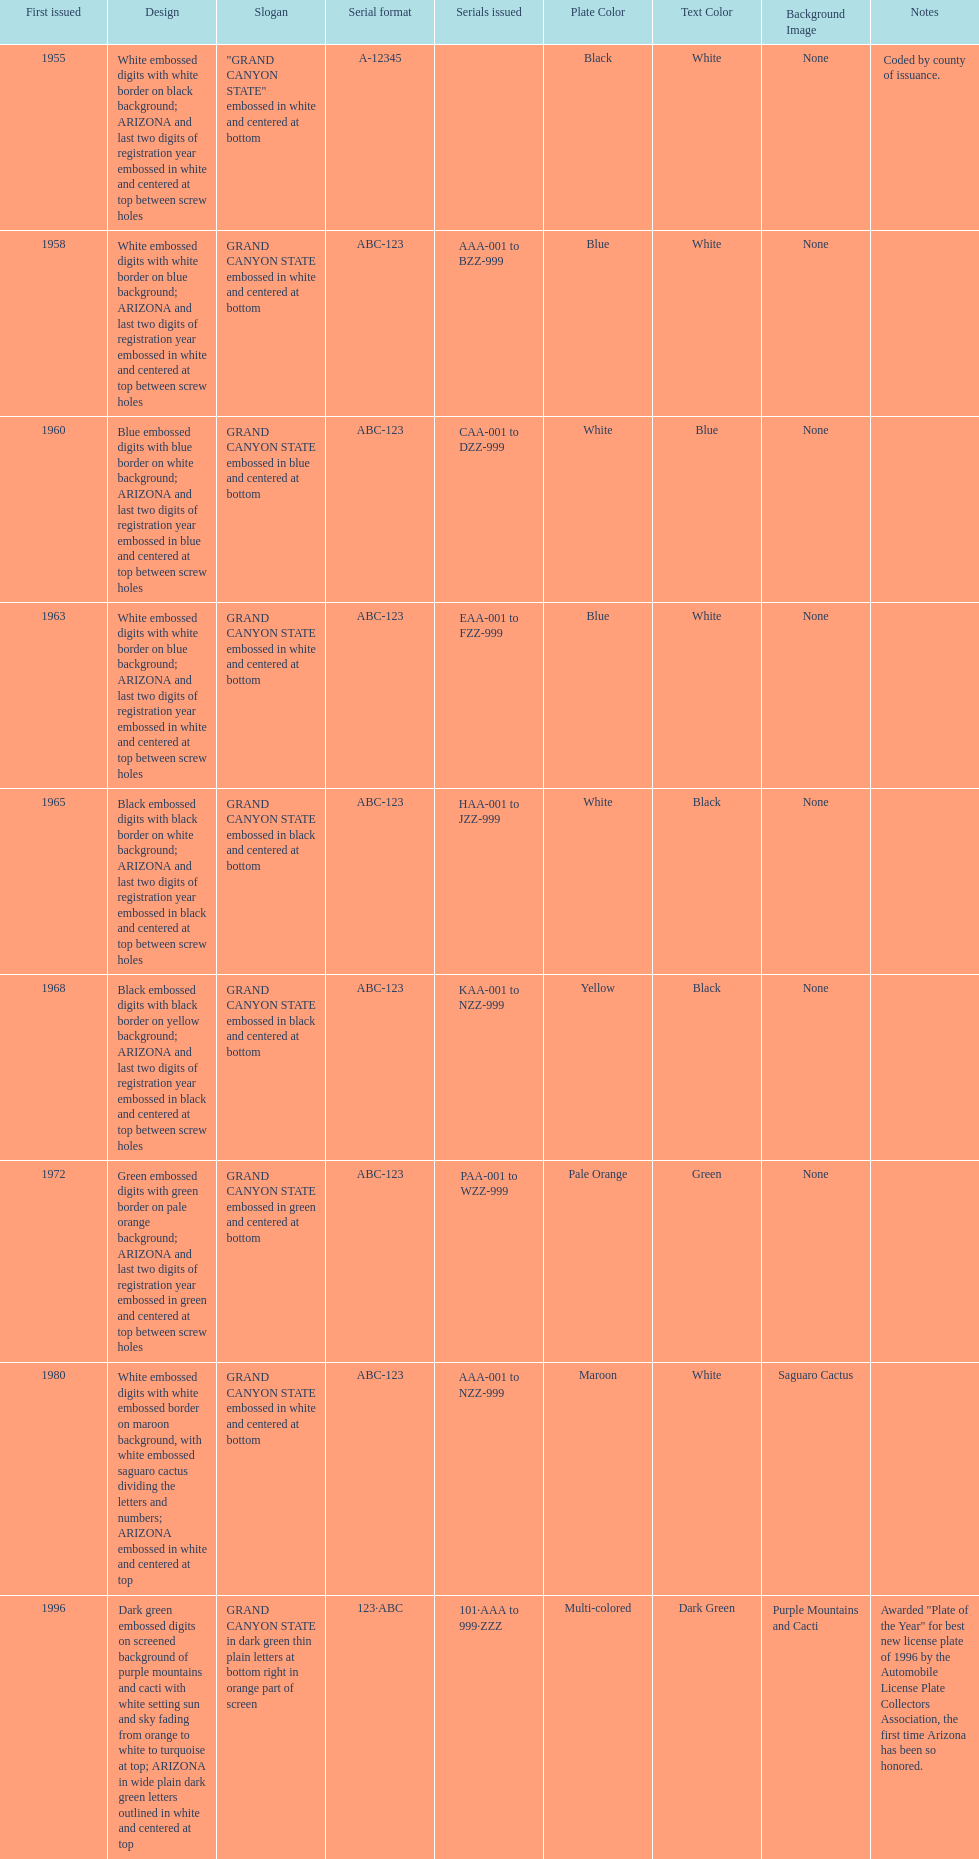In which year was the first arizona license plate created? 1955. 